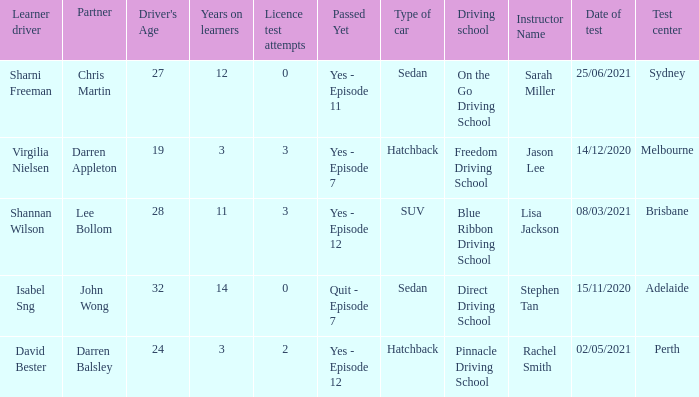What is the average number of years on learners of the drivers over the age of 24 with less than 0 attempts at the licence test? None. 